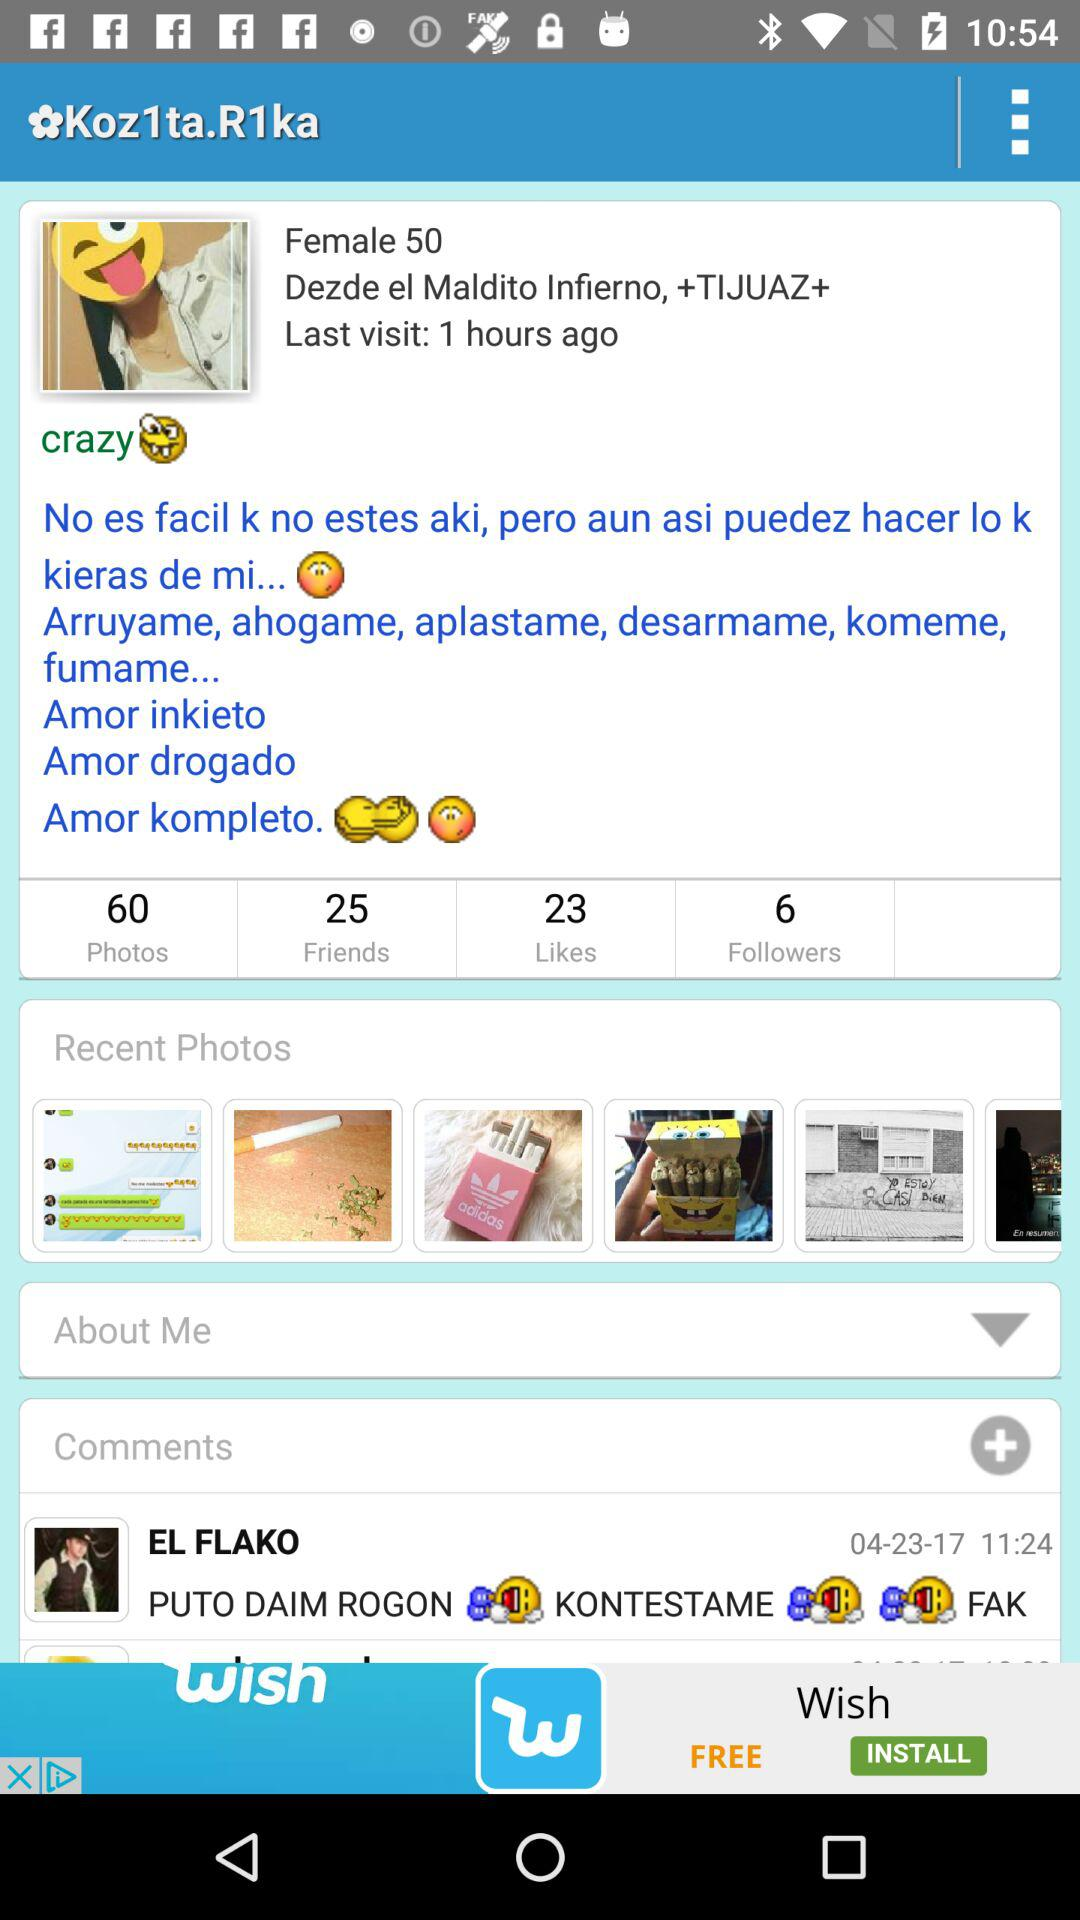How many followers are there? There are 6 followers. 